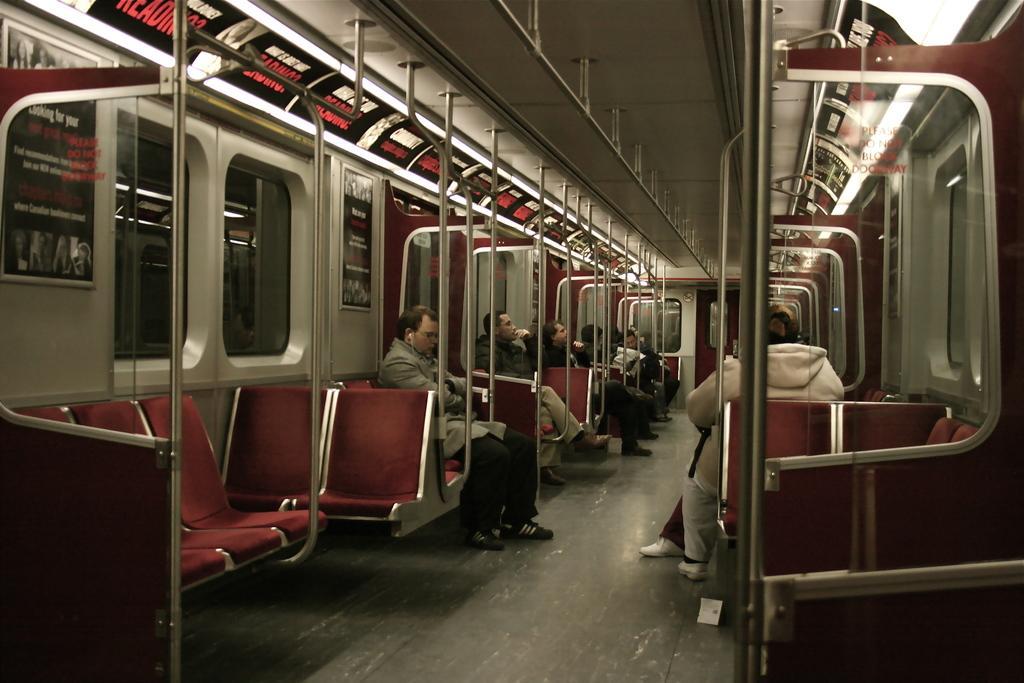Describe this image in one or two sentences. In this image we can see people sitting on the seats of a locomotive. 